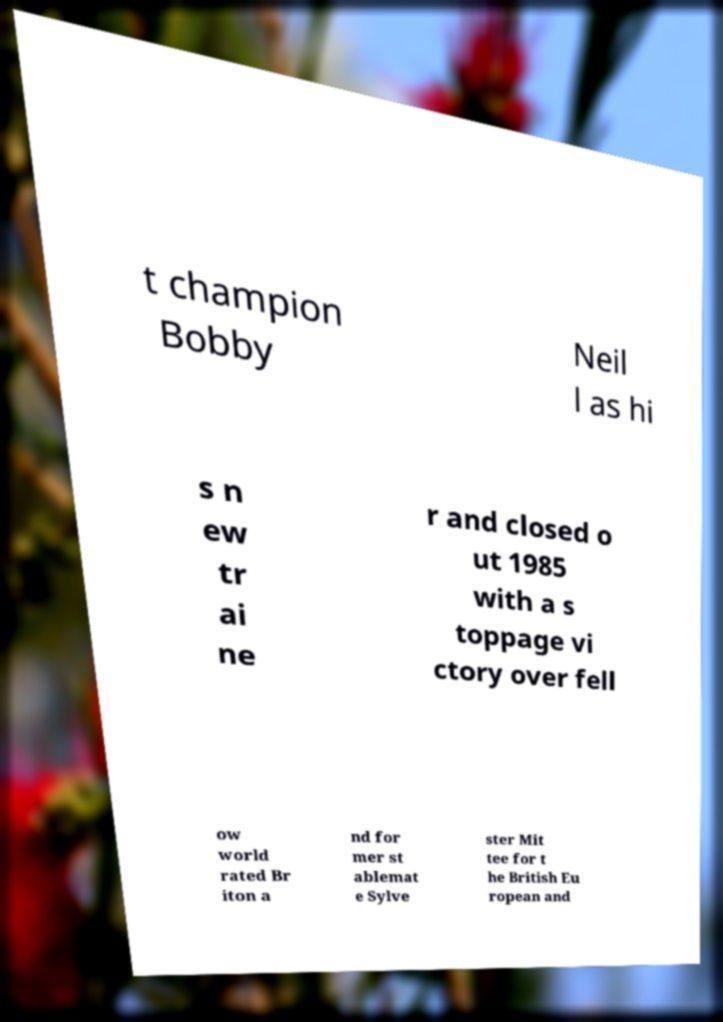For documentation purposes, I need the text within this image transcribed. Could you provide that? t champion Bobby Neil l as hi s n ew tr ai ne r and closed o ut 1985 with a s toppage vi ctory over fell ow world rated Br iton a nd for mer st ablemat e Sylve ster Mit tee for t he British Eu ropean and 